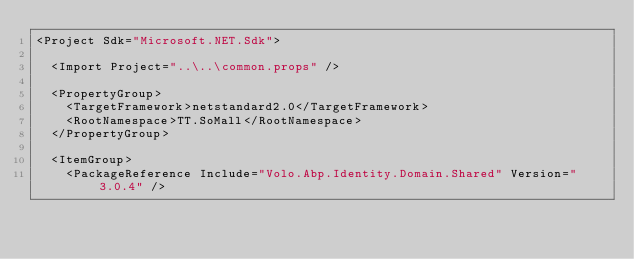Convert code to text. <code><loc_0><loc_0><loc_500><loc_500><_XML_><Project Sdk="Microsoft.NET.Sdk">

  <Import Project="..\..\common.props" />

  <PropertyGroup>
    <TargetFramework>netstandard2.0</TargetFramework>
    <RootNamespace>TT.SoMall</RootNamespace>
  </PropertyGroup>

  <ItemGroup>
    <PackageReference Include="Volo.Abp.Identity.Domain.Shared" Version="3.0.4" /></code> 